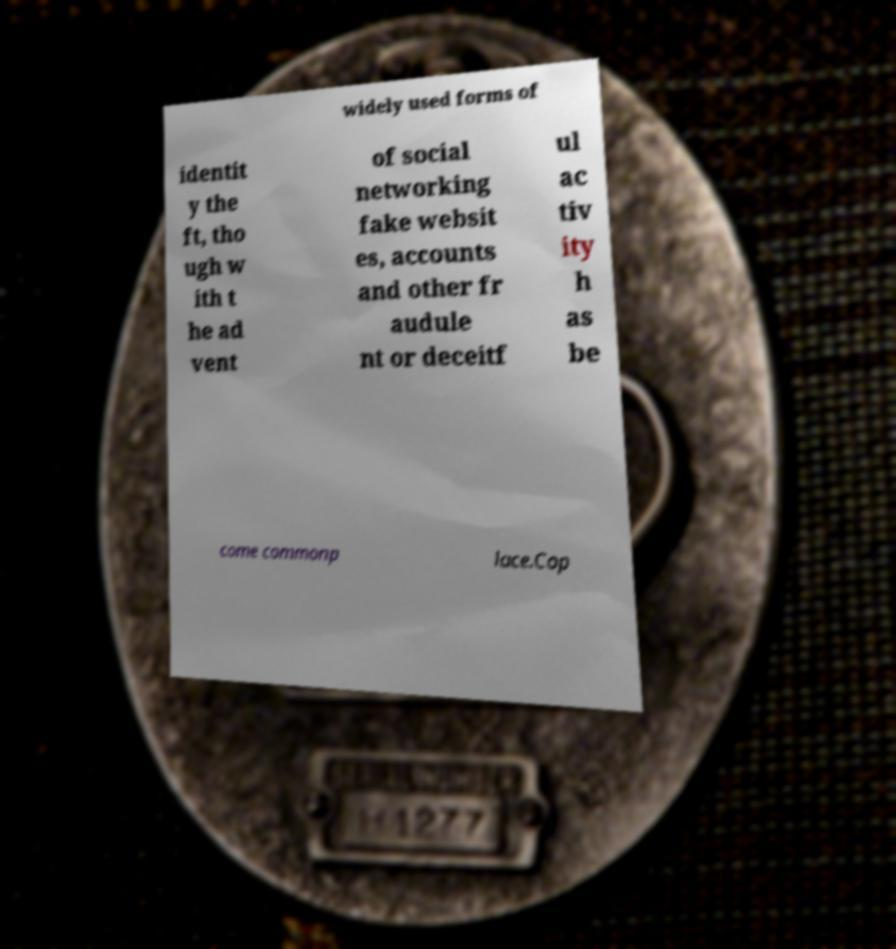Could you extract and type out the text from this image? widely used forms of identit y the ft, tho ugh w ith t he ad vent of social networking fake websit es, accounts and other fr audule nt or deceitf ul ac tiv ity h as be come commonp lace.Cop 